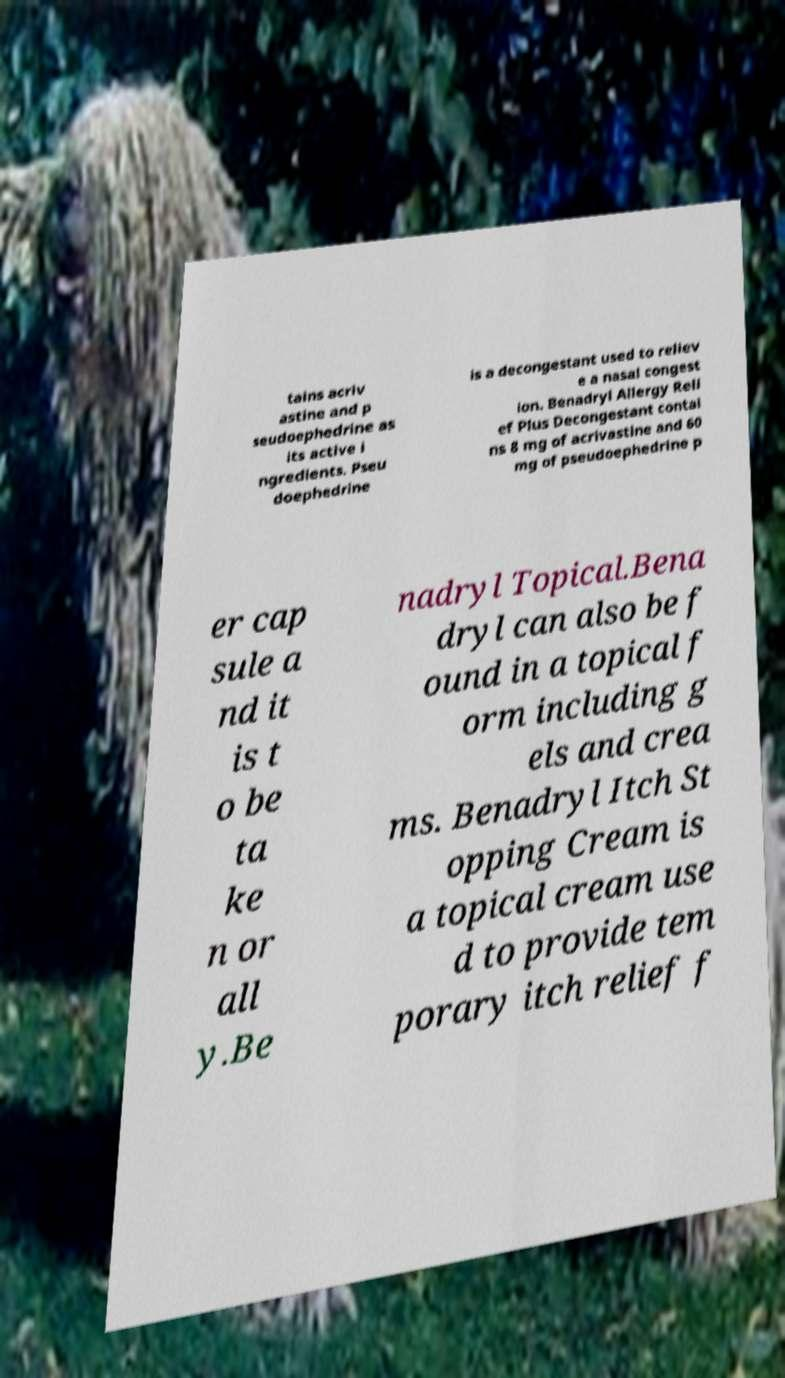Can you accurately transcribe the text from the provided image for me? tains acriv astine and p seudoephedrine as its active i ngredients. Pseu doephedrine is a decongestant used to reliev e a nasal congest ion. Benadryl Allergy Reli ef Plus Decongestant contai ns 8 mg of acrivastine and 60 mg of pseudoephedrine p er cap sule a nd it is t o be ta ke n or all y.Be nadryl Topical.Bena dryl can also be f ound in a topical f orm including g els and crea ms. Benadryl Itch St opping Cream is a topical cream use d to provide tem porary itch relief f 